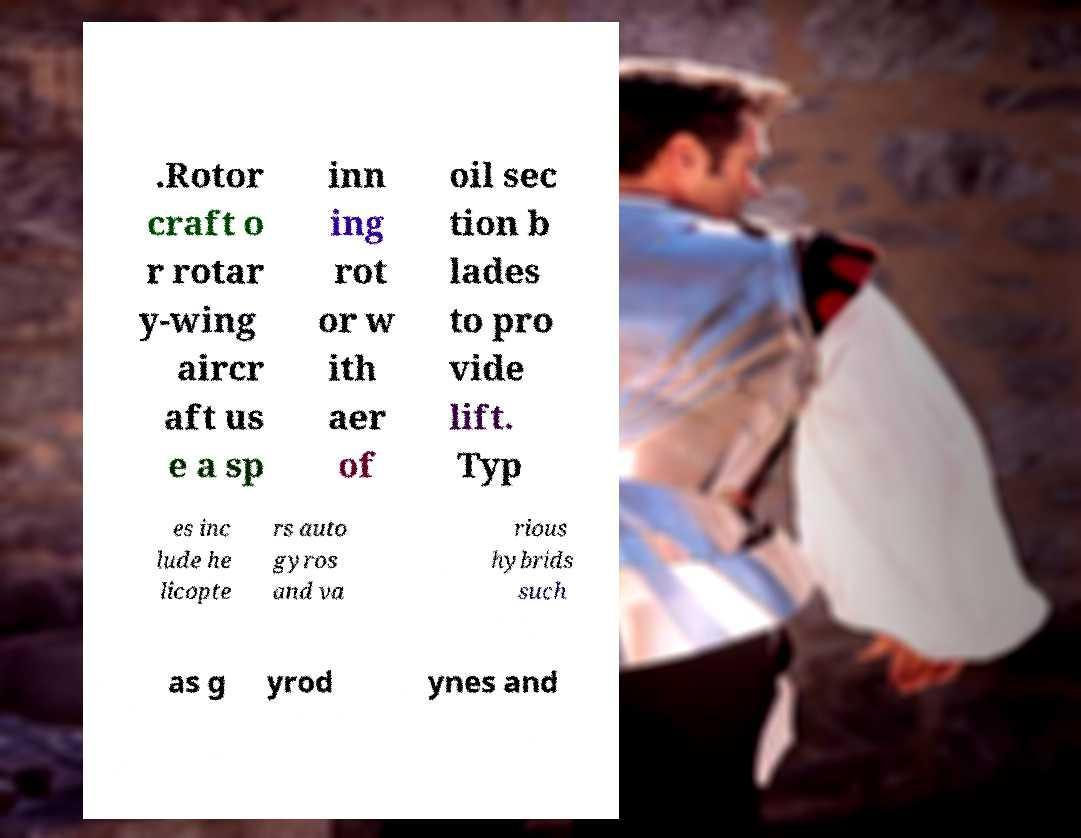There's text embedded in this image that I need extracted. Can you transcribe it verbatim? .Rotor craft o r rotar y-wing aircr aft us e a sp inn ing rot or w ith aer of oil sec tion b lades to pro vide lift. Typ es inc lude he licopte rs auto gyros and va rious hybrids such as g yrod ynes and 